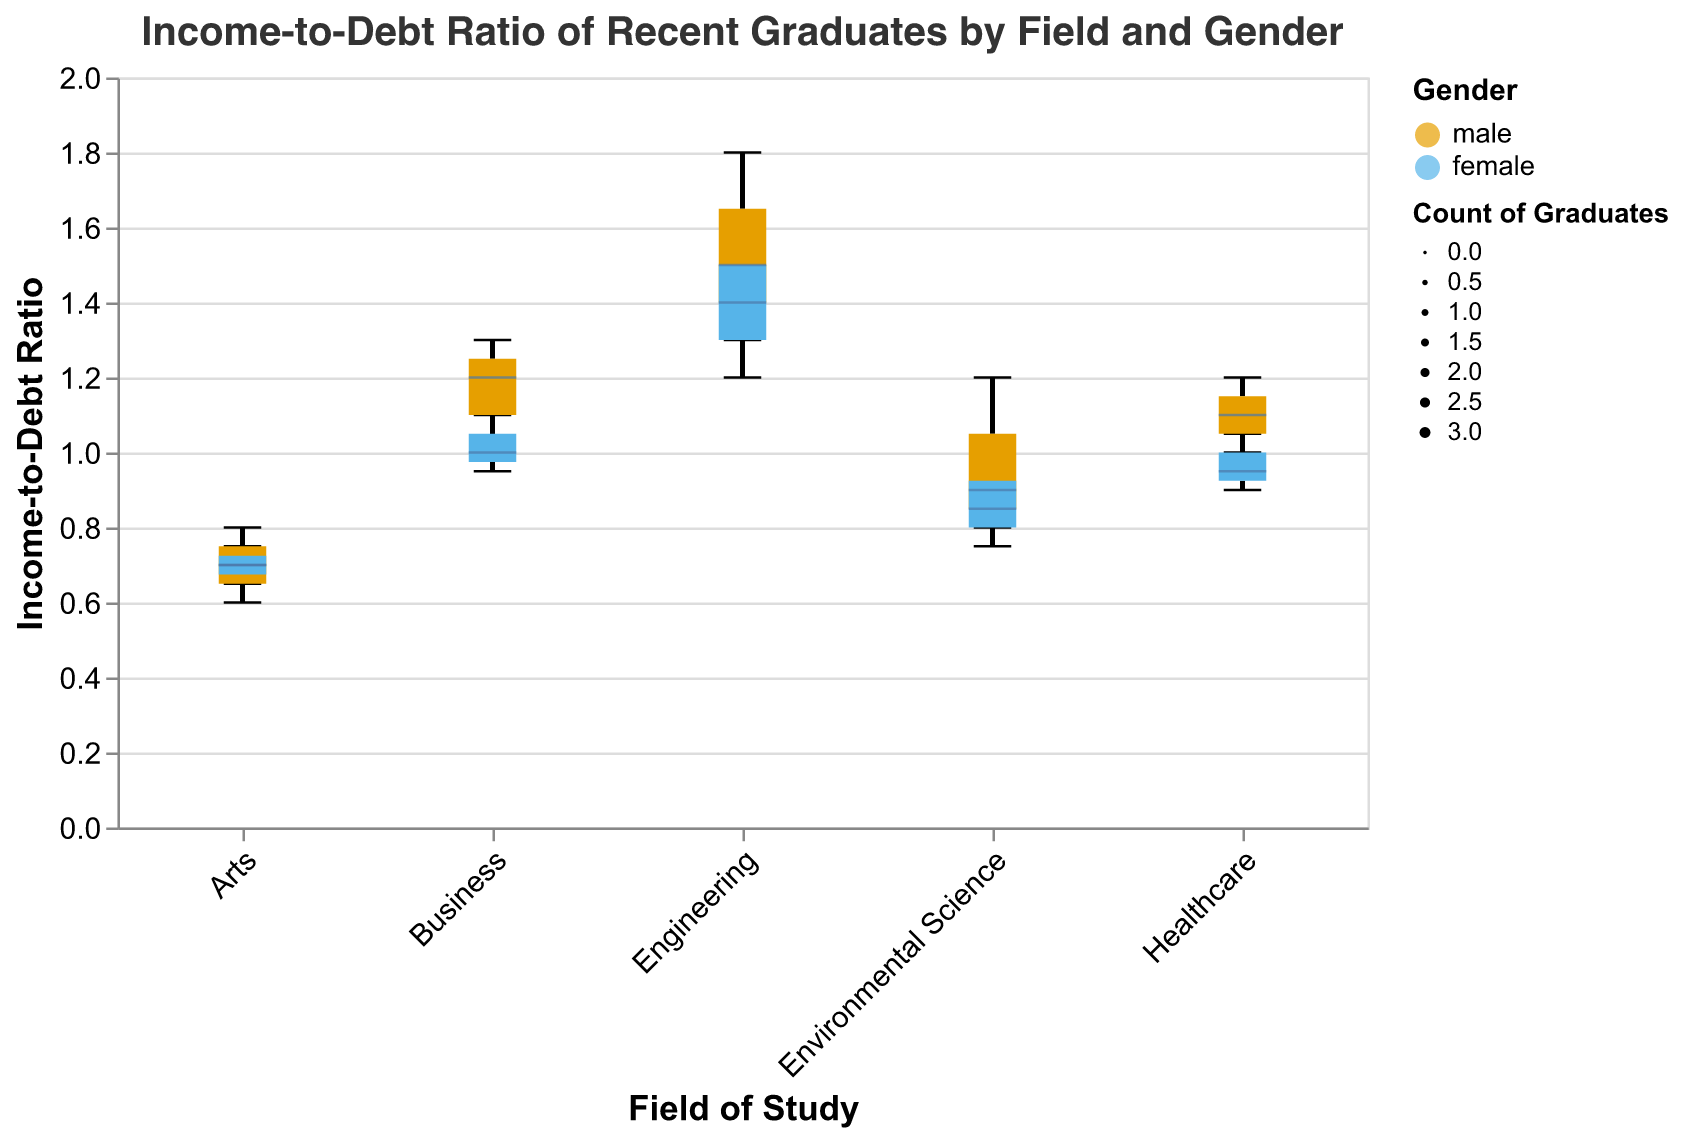What is the title of the chart? The title of the chart is located at the top and is "Income-to-Debt Ratio of Recent Graduates by Field and Gender".
Answer: Income-to-Debt Ratio of Recent Graduates by Field and Gender What fields are compared in this plot? The fields compared in the plot are listed along the x-axis. They include "Environmental Science", "Engineering", "Business", "Healthcare", and "Arts".
Answer: Environmental Science, Engineering, Business, Healthcare, Arts Which gender generally has a higher median income-to-debt ratio in Engineering? Observe the median lines within the boxes for male and female in the Engineering field. The male graduates have a higher median income-to-debt ratio.
Answer: Male What is the range of income-to-debt ratios for female graduates in Healthcare? The range is given by the minimum and maximum values indicated by the whiskers for females in Healthcare. These values are 0.9 (min) and 1.05 (max).
Answer: 0.9 to 1.05 Which field shows the greatest variation in income-to-debt ratios for female graduates? The variation can be seen from the spread of the boxplot. The Engineering field shows the greatest variation for female graduates, as it has the widest box.
Answer: Engineering Which field has the highest count of male graduates? The width of the boxplot indicates the count of graduates. The widest box for males appears in the Engineering field.
Answer: Engineering Among males, which field has the lowest range in income-to-debt ratio? The range is indicated by the distance between the whiskers. The Arts field has the lowest range among males, typically from about 0.6 to 0.8.
Answer: Arts How does the median income-to-debt ratio for female graduates in Business compare to that in Environmental Science? Compare the median lines within the boxes for female graduates in Business and Environmental Science. The ratio is about the same, nearly the line value for both fields appears near 1.0.
Answer: About the same What is the trend in income-to-debt ratios for recent graduates in multiple fields? The trend is seen across the different fields by examining the medians and box ranges. Generally, Engineering has the highest ratios, followed by Business, Healthcare, Environmental Science, and Arts at the lowest.
Answer: Engineering > Business > Healthcare > Environmental Science > Arts For which field do male and female graduates have the closest income-to-debt ratios? Look for fields where the boxes for male and female overlap the most. The Business field shows overlapping boxes, indicating close ratios for male and female graduates.
Answer: Business 